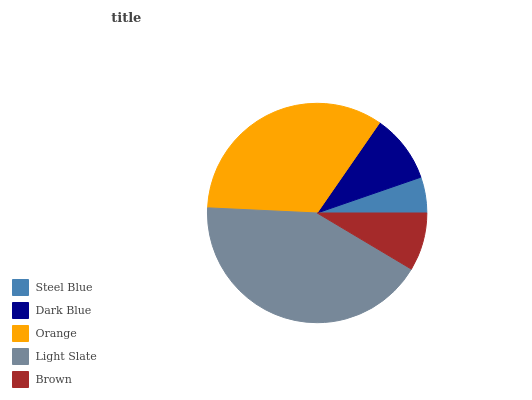Is Steel Blue the minimum?
Answer yes or no. Yes. Is Light Slate the maximum?
Answer yes or no. Yes. Is Dark Blue the minimum?
Answer yes or no. No. Is Dark Blue the maximum?
Answer yes or no. No. Is Dark Blue greater than Steel Blue?
Answer yes or no. Yes. Is Steel Blue less than Dark Blue?
Answer yes or no. Yes. Is Steel Blue greater than Dark Blue?
Answer yes or no. No. Is Dark Blue less than Steel Blue?
Answer yes or no. No. Is Dark Blue the high median?
Answer yes or no. Yes. Is Dark Blue the low median?
Answer yes or no. Yes. Is Orange the high median?
Answer yes or no. No. Is Brown the low median?
Answer yes or no. No. 